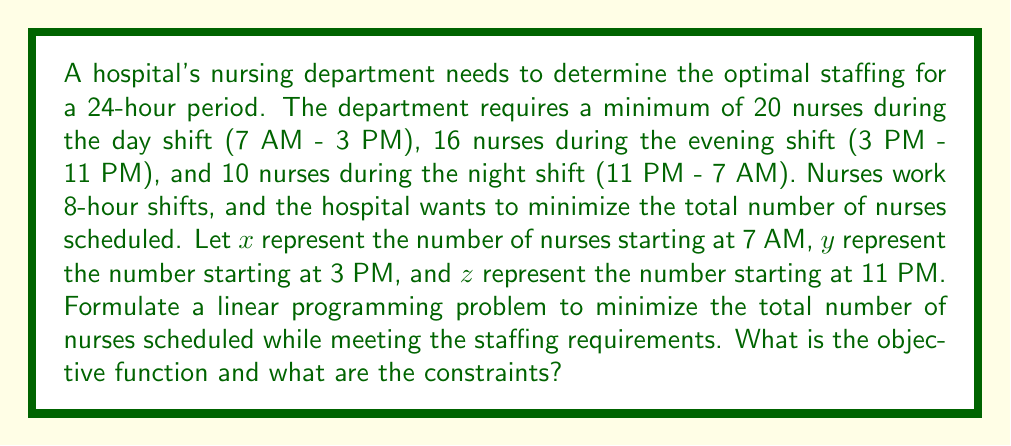Can you answer this question? To solve this problem, we need to formulate a linear programming problem with an objective function and constraints. Let's break it down step-by-step:

1. Define variables:
   $x$ = number of nurses starting at 7 AM
   $y$ = number of nurses starting at 3 PM
   $z$ = number of nurses starting at 11 PM

2. Objective function:
   We want to minimize the total number of nurses scheduled, which is the sum of nurses starting at each shift:
   Minimize: $x + y + z$

3. Constraints:
   a) Day shift (7 AM - 3 PM): Nurses who started at 7 AM
      $x \geq 20$

   b) Evening shift (3 PM - 11 PM): Nurses who started at 3 PM plus those who started at 7 AM
      $x + y \geq 16$

   c) Night shift (11 PM - 7 AM): Nurses who started at 11 PM plus those who started at 3 PM
      $y + z \geq 10$

   d) Non-negativity constraints:
      $x \geq 0$, $y \geq 0$, $z \geq 0$

4. Complete linear programming formulation:

   Minimize: $x + y + z$

   Subject to:
   $$\begin{align}
   x &\geq 20 \\
   x + y &\geq 16 \\
   y + z &\geq 10 \\
   x, y, z &\geq 0
   \end{align}$$

This formulation allows for the determination of the optimal staffing pattern while meeting the minimum staffing requirements for each shift and minimizing the total number of nurses scheduled.
Answer: Minimize: $x + y + z$
Subject to: $x \geq 20$, $x + y \geq 16$, $y + z \geq 10$, $x, y, z \geq 0$ 